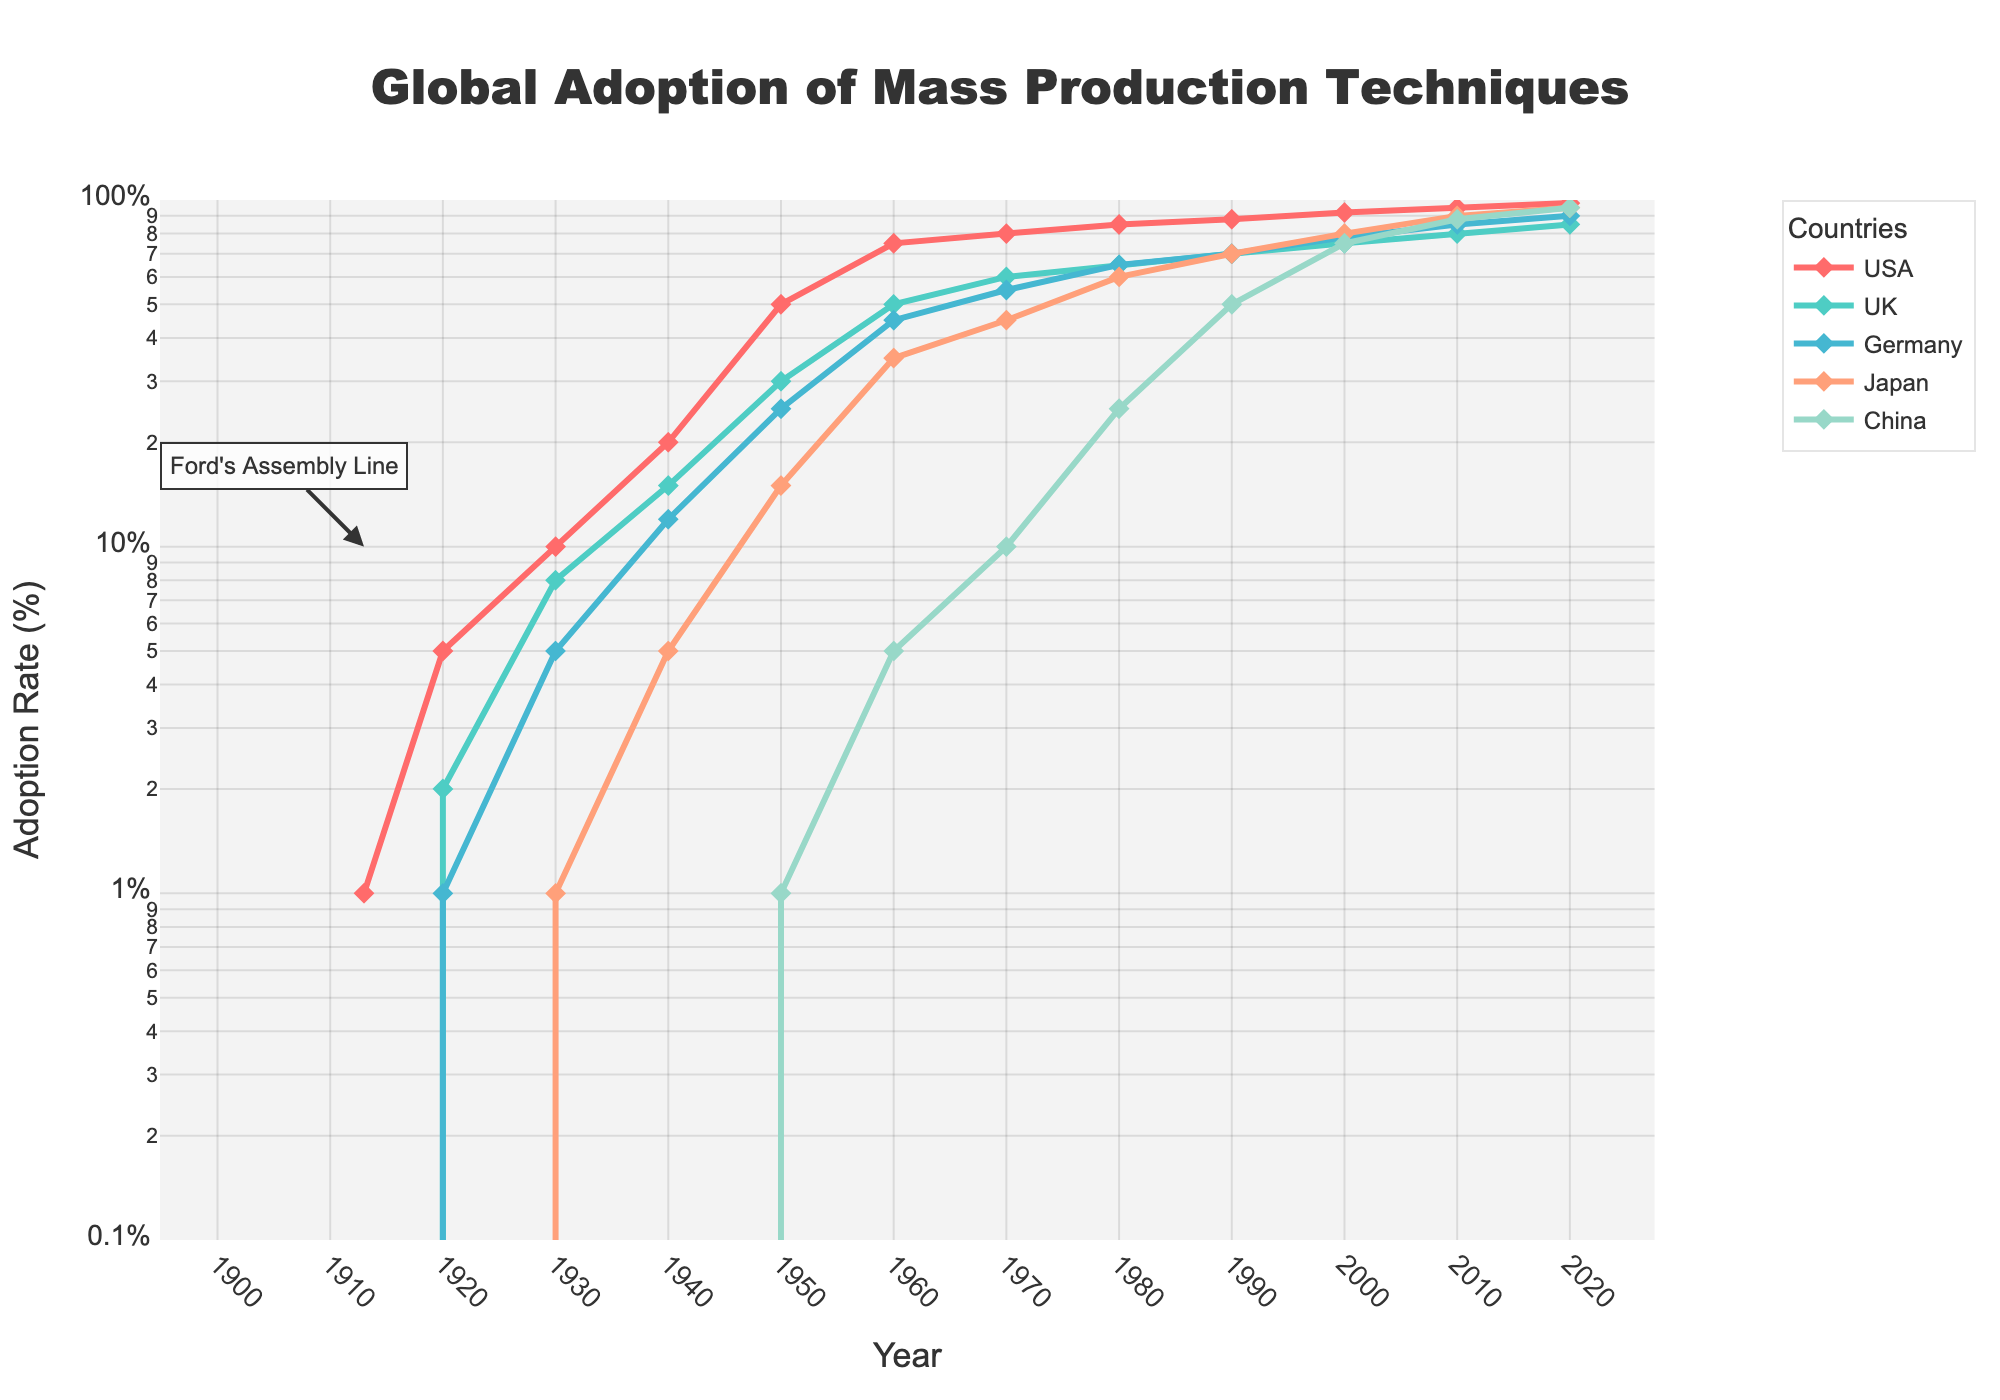When did China first adopt mass production techniques according to the plot? Review the data points on the chart to see the first year where China's adoption rate is recorded above 0. The year 1950 shows China's adoption rate reaches 1%.
Answer: 1950 Which country had the highest adoption rate in 1980? Observe the data points for the year 1980 and compare them across the countries. The USA has the highest adoption rate of 85%.
Answer: USA What is the adoption rate difference between Japan and Germany in 2000? Look at the data points for Japan and Germany in the year 2000. Japan has 80% and Germany has 78%. Subtract Germany's rate from Japan's rate: 80% - 78% = 2%.
Answer: 2% How does the adoption rate of mass production in China compare from 1960 to 1970? Examine the points for China in 1960 and 1970. The adoption rate increased from 5% in 1960 to 10% in 1970.
Answer: Increased What's the average adoption rate for the USA over the entire period shown? Sum the adoption rates for the USA from 1913 to 2020 and divide by the number of data points (12). The rates are [1, 5, 10, 20, 50, 75, 80, 85, 88, 92, 95, 98]. The sum is 699. The average is 699 / 12 = 58.25.
Answer: 58.25 Which countries' adoption rates reach 90% in 2020? Look at the data points in 2020 and see which ones are above or equal to 90%. Japan and China both have an adoption rate of 95% while Germany has 90%.
Answer: Japan, China, Germany At what year does the UK first surpass a 50% adoption rate? Review the UK data points and find the first year where the adoption rate is greater than 50%. In 1960, the UK's adoption rate is 50%, but it is 60% in 1970. So, it is 1970.
Answer: 1970 Compare the trend in adoption rates for the USA and Japan from 1913 to 2020. Observe the USA and Japan lines from 1913 to 2020. The USA shows a sharp increase in the early 20th century and maintains a high rate. Japan starts much later but shows a rapid increase, especially after the 1950s, and eventually converges with the USA's rates by 2020.
Answer: USA higher initially, Japan catches up What trend can be observed for Germany's adoption rate between 1930 and 1950? Check Germany's points between 1930 and 1950. The adoption rate increases from 5% in 1930 to 25% in 1950, indicating a period of substantial growth.
Answer: Increasing trend 